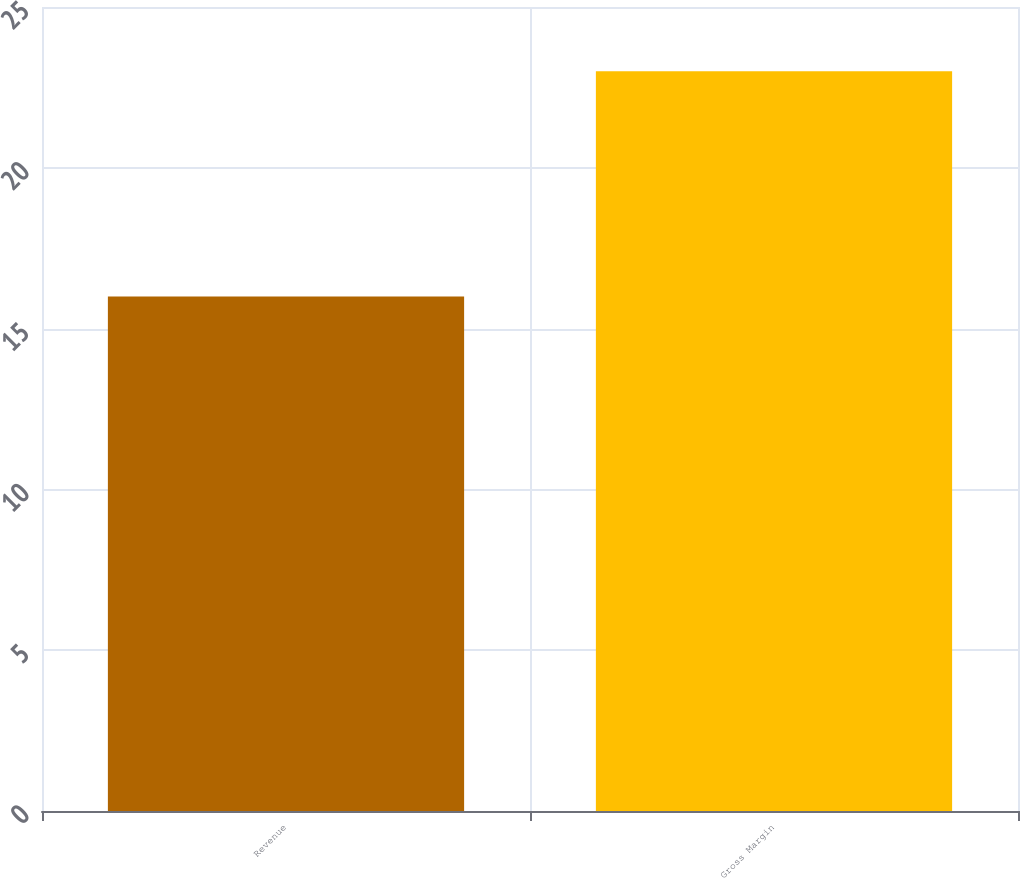<chart> <loc_0><loc_0><loc_500><loc_500><bar_chart><fcel>Revenue<fcel>Gross Margin<nl><fcel>16<fcel>23<nl></chart> 